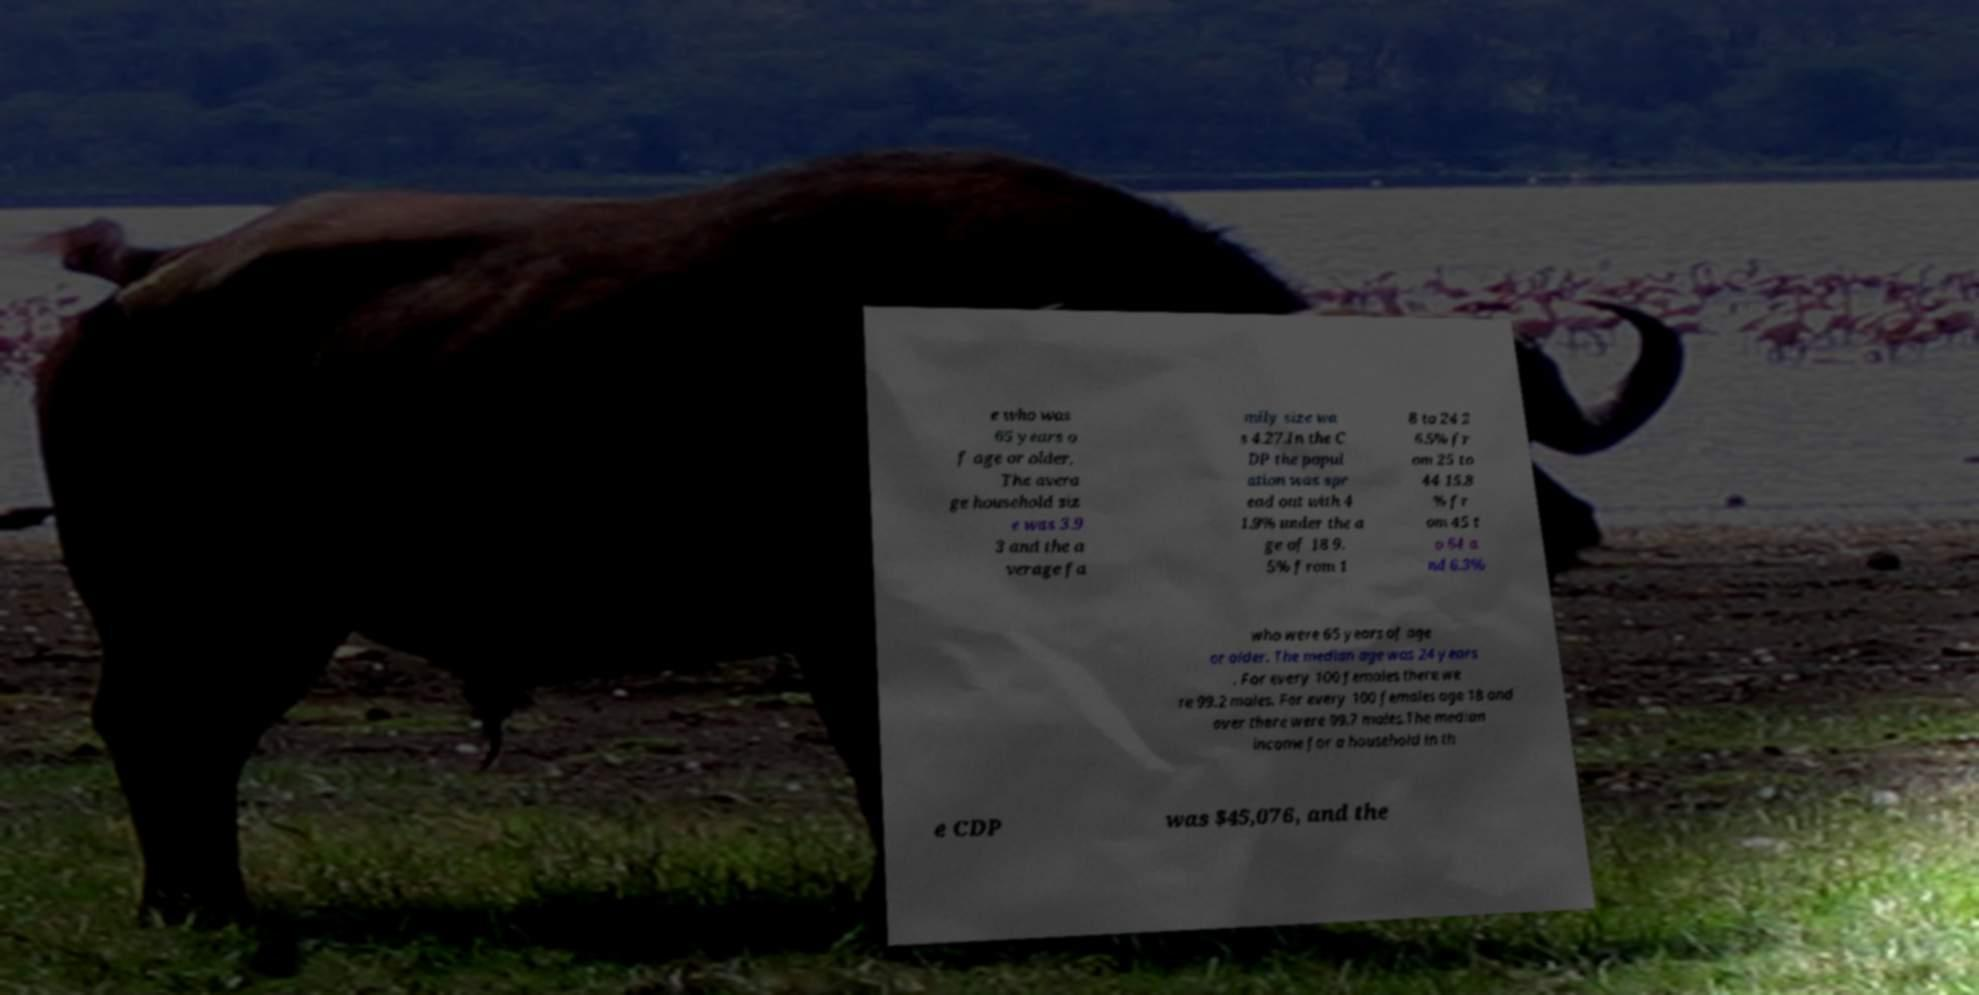Please identify and transcribe the text found in this image. e who was 65 years o f age or older. The avera ge household siz e was 3.9 3 and the a verage fa mily size wa s 4.27.In the C DP the popul ation was spr ead out with 4 1.9% under the a ge of 18 9. 5% from 1 8 to 24 2 6.5% fr om 25 to 44 15.8 % fr om 45 t o 64 a nd 6.3% who were 65 years of age or older. The median age was 24 years . For every 100 females there we re 99.2 males. For every 100 females age 18 and over there were 99.7 males.The median income for a household in th e CDP was $45,076, and the 